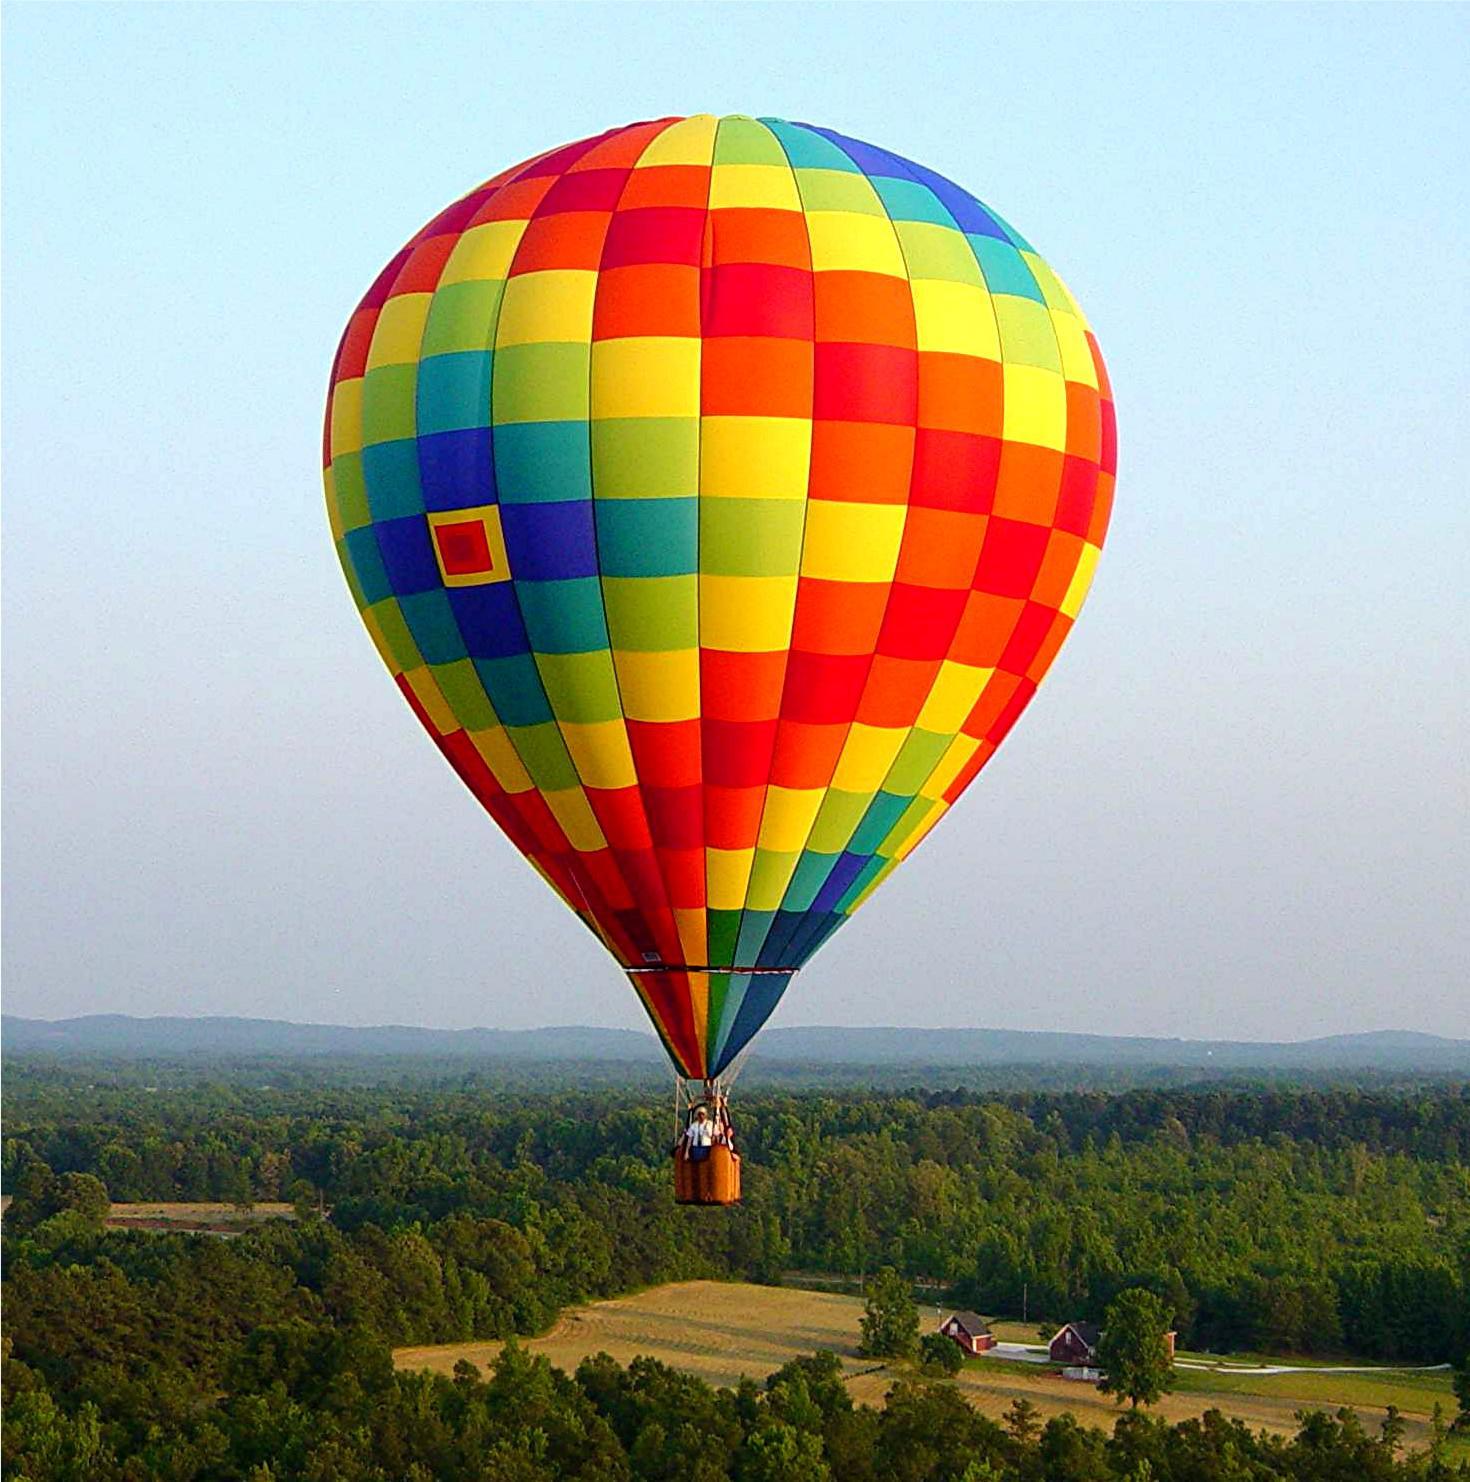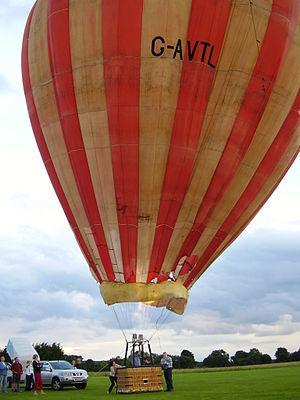The first image is the image on the left, the second image is the image on the right. For the images shown, is this caption "Left image shows a balloon with multi-colored squarish shapes." true? Answer yes or no. Yes. The first image is the image on the left, the second image is the image on the right. For the images displayed, is the sentence "One hot air balloon is sitting on a grassy area and one is floating in the air." factually correct? Answer yes or no. Yes. 